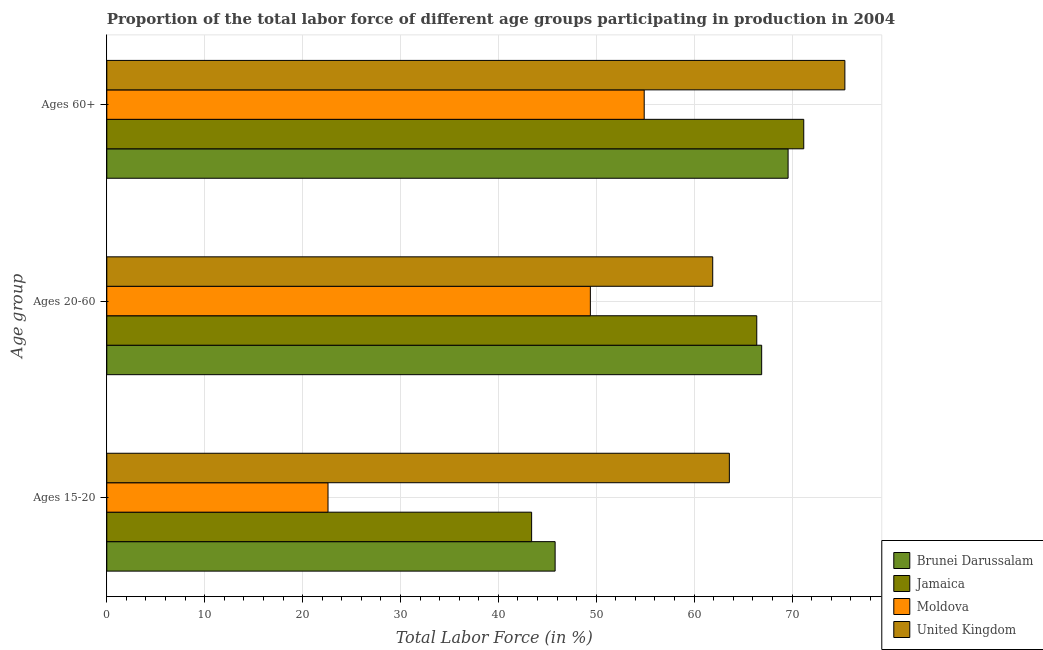Are the number of bars per tick equal to the number of legend labels?
Give a very brief answer. Yes. Are the number of bars on each tick of the Y-axis equal?
Your answer should be very brief. Yes. How many bars are there on the 3rd tick from the top?
Give a very brief answer. 4. How many bars are there on the 3rd tick from the bottom?
Offer a very short reply. 4. What is the label of the 2nd group of bars from the top?
Your answer should be compact. Ages 20-60. What is the percentage of labor force within the age group 20-60 in Jamaica?
Give a very brief answer. 66.4. Across all countries, what is the maximum percentage of labor force within the age group 20-60?
Your response must be concise. 66.9. Across all countries, what is the minimum percentage of labor force within the age group 15-20?
Provide a succinct answer. 22.6. In which country was the percentage of labor force within the age group 20-60 minimum?
Give a very brief answer. Moldova. What is the total percentage of labor force above age 60 in the graph?
Ensure brevity in your answer.  271.1. What is the difference between the percentage of labor force within the age group 20-60 in Jamaica and that in Moldova?
Your answer should be compact. 17. What is the difference between the percentage of labor force within the age group 15-20 in Moldova and the percentage of labor force within the age group 20-60 in United Kingdom?
Provide a succinct answer. -39.3. What is the average percentage of labor force within the age group 15-20 per country?
Make the answer very short. 43.85. What is the difference between the percentage of labor force above age 60 and percentage of labor force within the age group 20-60 in United Kingdom?
Your response must be concise. 13.5. In how many countries, is the percentage of labor force above age 60 greater than 30 %?
Keep it short and to the point. 4. What is the ratio of the percentage of labor force within the age group 15-20 in United Kingdom to that in Moldova?
Your answer should be compact. 2.81. Is the difference between the percentage of labor force within the age group 15-20 in Moldova and Brunei Darussalam greater than the difference between the percentage of labor force above age 60 in Moldova and Brunei Darussalam?
Give a very brief answer. No. What is the difference between the highest and the second highest percentage of labor force within the age group 15-20?
Provide a succinct answer. 17.8. What is the difference between the highest and the lowest percentage of labor force within the age group 20-60?
Provide a succinct answer. 17.5. In how many countries, is the percentage of labor force within the age group 15-20 greater than the average percentage of labor force within the age group 15-20 taken over all countries?
Keep it short and to the point. 2. Is the sum of the percentage of labor force above age 60 in Jamaica and United Kingdom greater than the maximum percentage of labor force within the age group 20-60 across all countries?
Your answer should be very brief. Yes. What does the 3rd bar from the top in Ages 60+ represents?
Provide a short and direct response. Jamaica. What does the 3rd bar from the bottom in Ages 20-60 represents?
Your response must be concise. Moldova. Is it the case that in every country, the sum of the percentage of labor force within the age group 15-20 and percentage of labor force within the age group 20-60 is greater than the percentage of labor force above age 60?
Offer a very short reply. Yes. Are all the bars in the graph horizontal?
Your answer should be compact. Yes. What is the difference between two consecutive major ticks on the X-axis?
Your answer should be compact. 10. Are the values on the major ticks of X-axis written in scientific E-notation?
Keep it short and to the point. No. Does the graph contain grids?
Your response must be concise. Yes. How many legend labels are there?
Give a very brief answer. 4. How are the legend labels stacked?
Offer a very short reply. Vertical. What is the title of the graph?
Provide a short and direct response. Proportion of the total labor force of different age groups participating in production in 2004. What is the label or title of the Y-axis?
Ensure brevity in your answer.  Age group. What is the Total Labor Force (in %) in Brunei Darussalam in Ages 15-20?
Ensure brevity in your answer.  45.8. What is the Total Labor Force (in %) in Jamaica in Ages 15-20?
Your response must be concise. 43.4. What is the Total Labor Force (in %) of Moldova in Ages 15-20?
Keep it short and to the point. 22.6. What is the Total Labor Force (in %) in United Kingdom in Ages 15-20?
Provide a short and direct response. 63.6. What is the Total Labor Force (in %) of Brunei Darussalam in Ages 20-60?
Provide a short and direct response. 66.9. What is the Total Labor Force (in %) of Jamaica in Ages 20-60?
Keep it short and to the point. 66.4. What is the Total Labor Force (in %) in Moldova in Ages 20-60?
Your answer should be compact. 49.4. What is the Total Labor Force (in %) in United Kingdom in Ages 20-60?
Give a very brief answer. 61.9. What is the Total Labor Force (in %) in Brunei Darussalam in Ages 60+?
Give a very brief answer. 69.6. What is the Total Labor Force (in %) in Jamaica in Ages 60+?
Ensure brevity in your answer.  71.2. What is the Total Labor Force (in %) of Moldova in Ages 60+?
Keep it short and to the point. 54.9. What is the Total Labor Force (in %) in United Kingdom in Ages 60+?
Give a very brief answer. 75.4. Across all Age group, what is the maximum Total Labor Force (in %) in Brunei Darussalam?
Offer a terse response. 69.6. Across all Age group, what is the maximum Total Labor Force (in %) of Jamaica?
Offer a very short reply. 71.2. Across all Age group, what is the maximum Total Labor Force (in %) in Moldova?
Make the answer very short. 54.9. Across all Age group, what is the maximum Total Labor Force (in %) of United Kingdom?
Your answer should be compact. 75.4. Across all Age group, what is the minimum Total Labor Force (in %) in Brunei Darussalam?
Ensure brevity in your answer.  45.8. Across all Age group, what is the minimum Total Labor Force (in %) of Jamaica?
Offer a very short reply. 43.4. Across all Age group, what is the minimum Total Labor Force (in %) of Moldova?
Your answer should be very brief. 22.6. Across all Age group, what is the minimum Total Labor Force (in %) of United Kingdom?
Provide a short and direct response. 61.9. What is the total Total Labor Force (in %) in Brunei Darussalam in the graph?
Offer a very short reply. 182.3. What is the total Total Labor Force (in %) of Jamaica in the graph?
Make the answer very short. 181. What is the total Total Labor Force (in %) of Moldova in the graph?
Provide a short and direct response. 126.9. What is the total Total Labor Force (in %) in United Kingdom in the graph?
Make the answer very short. 200.9. What is the difference between the Total Labor Force (in %) in Brunei Darussalam in Ages 15-20 and that in Ages 20-60?
Make the answer very short. -21.1. What is the difference between the Total Labor Force (in %) in Jamaica in Ages 15-20 and that in Ages 20-60?
Offer a terse response. -23. What is the difference between the Total Labor Force (in %) in Moldova in Ages 15-20 and that in Ages 20-60?
Provide a short and direct response. -26.8. What is the difference between the Total Labor Force (in %) of United Kingdom in Ages 15-20 and that in Ages 20-60?
Give a very brief answer. 1.7. What is the difference between the Total Labor Force (in %) of Brunei Darussalam in Ages 15-20 and that in Ages 60+?
Make the answer very short. -23.8. What is the difference between the Total Labor Force (in %) in Jamaica in Ages 15-20 and that in Ages 60+?
Ensure brevity in your answer.  -27.8. What is the difference between the Total Labor Force (in %) in Moldova in Ages 15-20 and that in Ages 60+?
Keep it short and to the point. -32.3. What is the difference between the Total Labor Force (in %) in United Kingdom in Ages 15-20 and that in Ages 60+?
Provide a succinct answer. -11.8. What is the difference between the Total Labor Force (in %) of Brunei Darussalam in Ages 20-60 and that in Ages 60+?
Provide a succinct answer. -2.7. What is the difference between the Total Labor Force (in %) of Jamaica in Ages 20-60 and that in Ages 60+?
Your response must be concise. -4.8. What is the difference between the Total Labor Force (in %) of Moldova in Ages 20-60 and that in Ages 60+?
Keep it short and to the point. -5.5. What is the difference between the Total Labor Force (in %) in United Kingdom in Ages 20-60 and that in Ages 60+?
Ensure brevity in your answer.  -13.5. What is the difference between the Total Labor Force (in %) of Brunei Darussalam in Ages 15-20 and the Total Labor Force (in %) of Jamaica in Ages 20-60?
Keep it short and to the point. -20.6. What is the difference between the Total Labor Force (in %) in Brunei Darussalam in Ages 15-20 and the Total Labor Force (in %) in United Kingdom in Ages 20-60?
Ensure brevity in your answer.  -16.1. What is the difference between the Total Labor Force (in %) in Jamaica in Ages 15-20 and the Total Labor Force (in %) in United Kingdom in Ages 20-60?
Your answer should be very brief. -18.5. What is the difference between the Total Labor Force (in %) in Moldova in Ages 15-20 and the Total Labor Force (in %) in United Kingdom in Ages 20-60?
Offer a very short reply. -39.3. What is the difference between the Total Labor Force (in %) of Brunei Darussalam in Ages 15-20 and the Total Labor Force (in %) of Jamaica in Ages 60+?
Your answer should be compact. -25.4. What is the difference between the Total Labor Force (in %) in Brunei Darussalam in Ages 15-20 and the Total Labor Force (in %) in Moldova in Ages 60+?
Keep it short and to the point. -9.1. What is the difference between the Total Labor Force (in %) in Brunei Darussalam in Ages 15-20 and the Total Labor Force (in %) in United Kingdom in Ages 60+?
Provide a succinct answer. -29.6. What is the difference between the Total Labor Force (in %) in Jamaica in Ages 15-20 and the Total Labor Force (in %) in Moldova in Ages 60+?
Your response must be concise. -11.5. What is the difference between the Total Labor Force (in %) in Jamaica in Ages 15-20 and the Total Labor Force (in %) in United Kingdom in Ages 60+?
Provide a short and direct response. -32. What is the difference between the Total Labor Force (in %) in Moldova in Ages 15-20 and the Total Labor Force (in %) in United Kingdom in Ages 60+?
Your answer should be compact. -52.8. What is the difference between the Total Labor Force (in %) of Brunei Darussalam in Ages 20-60 and the Total Labor Force (in %) of Jamaica in Ages 60+?
Offer a terse response. -4.3. What is the average Total Labor Force (in %) of Brunei Darussalam per Age group?
Provide a short and direct response. 60.77. What is the average Total Labor Force (in %) in Jamaica per Age group?
Your answer should be compact. 60.33. What is the average Total Labor Force (in %) in Moldova per Age group?
Offer a terse response. 42.3. What is the average Total Labor Force (in %) of United Kingdom per Age group?
Offer a terse response. 66.97. What is the difference between the Total Labor Force (in %) in Brunei Darussalam and Total Labor Force (in %) in Jamaica in Ages 15-20?
Offer a very short reply. 2.4. What is the difference between the Total Labor Force (in %) of Brunei Darussalam and Total Labor Force (in %) of Moldova in Ages 15-20?
Provide a short and direct response. 23.2. What is the difference between the Total Labor Force (in %) of Brunei Darussalam and Total Labor Force (in %) of United Kingdom in Ages 15-20?
Your response must be concise. -17.8. What is the difference between the Total Labor Force (in %) of Jamaica and Total Labor Force (in %) of Moldova in Ages 15-20?
Offer a terse response. 20.8. What is the difference between the Total Labor Force (in %) of Jamaica and Total Labor Force (in %) of United Kingdom in Ages 15-20?
Provide a succinct answer. -20.2. What is the difference between the Total Labor Force (in %) in Moldova and Total Labor Force (in %) in United Kingdom in Ages 15-20?
Keep it short and to the point. -41. What is the difference between the Total Labor Force (in %) of Brunei Darussalam and Total Labor Force (in %) of United Kingdom in Ages 20-60?
Your response must be concise. 5. What is the difference between the Total Labor Force (in %) in Moldova and Total Labor Force (in %) in United Kingdom in Ages 20-60?
Provide a short and direct response. -12.5. What is the difference between the Total Labor Force (in %) of Moldova and Total Labor Force (in %) of United Kingdom in Ages 60+?
Offer a very short reply. -20.5. What is the ratio of the Total Labor Force (in %) in Brunei Darussalam in Ages 15-20 to that in Ages 20-60?
Provide a succinct answer. 0.68. What is the ratio of the Total Labor Force (in %) in Jamaica in Ages 15-20 to that in Ages 20-60?
Your answer should be very brief. 0.65. What is the ratio of the Total Labor Force (in %) of Moldova in Ages 15-20 to that in Ages 20-60?
Keep it short and to the point. 0.46. What is the ratio of the Total Labor Force (in %) in United Kingdom in Ages 15-20 to that in Ages 20-60?
Your answer should be compact. 1.03. What is the ratio of the Total Labor Force (in %) in Brunei Darussalam in Ages 15-20 to that in Ages 60+?
Ensure brevity in your answer.  0.66. What is the ratio of the Total Labor Force (in %) of Jamaica in Ages 15-20 to that in Ages 60+?
Offer a terse response. 0.61. What is the ratio of the Total Labor Force (in %) of Moldova in Ages 15-20 to that in Ages 60+?
Keep it short and to the point. 0.41. What is the ratio of the Total Labor Force (in %) in United Kingdom in Ages 15-20 to that in Ages 60+?
Your response must be concise. 0.84. What is the ratio of the Total Labor Force (in %) of Brunei Darussalam in Ages 20-60 to that in Ages 60+?
Keep it short and to the point. 0.96. What is the ratio of the Total Labor Force (in %) in Jamaica in Ages 20-60 to that in Ages 60+?
Provide a short and direct response. 0.93. What is the ratio of the Total Labor Force (in %) in Moldova in Ages 20-60 to that in Ages 60+?
Your answer should be very brief. 0.9. What is the ratio of the Total Labor Force (in %) of United Kingdom in Ages 20-60 to that in Ages 60+?
Offer a very short reply. 0.82. What is the difference between the highest and the second highest Total Labor Force (in %) in Brunei Darussalam?
Provide a short and direct response. 2.7. What is the difference between the highest and the second highest Total Labor Force (in %) in Jamaica?
Offer a very short reply. 4.8. What is the difference between the highest and the lowest Total Labor Force (in %) of Brunei Darussalam?
Give a very brief answer. 23.8. What is the difference between the highest and the lowest Total Labor Force (in %) in Jamaica?
Give a very brief answer. 27.8. What is the difference between the highest and the lowest Total Labor Force (in %) in Moldova?
Your answer should be very brief. 32.3. 